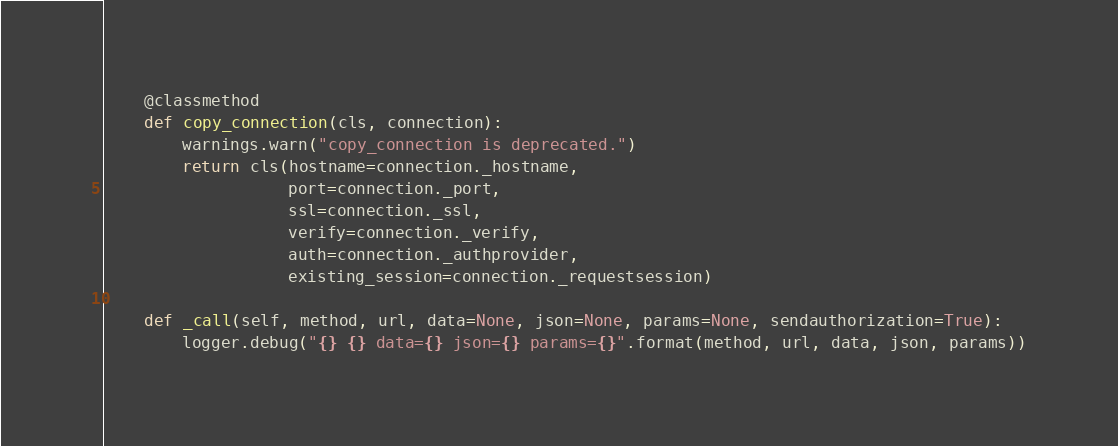<code> <loc_0><loc_0><loc_500><loc_500><_Python_>
    @classmethod
    def copy_connection(cls, connection):
        warnings.warn("copy_connection is deprecated.")
        return cls(hostname=connection._hostname,
                   port=connection._port,
                   ssl=connection._ssl,
                   verify=connection._verify,
                   auth=connection._authprovider,
                   existing_session=connection._requestsession)

    def _call(self, method, url, data=None, json=None, params=None, sendauthorization=True):
        logger.debug("{} {} data={} json={} params={}".format(method, url, data, json, params))
</code> 